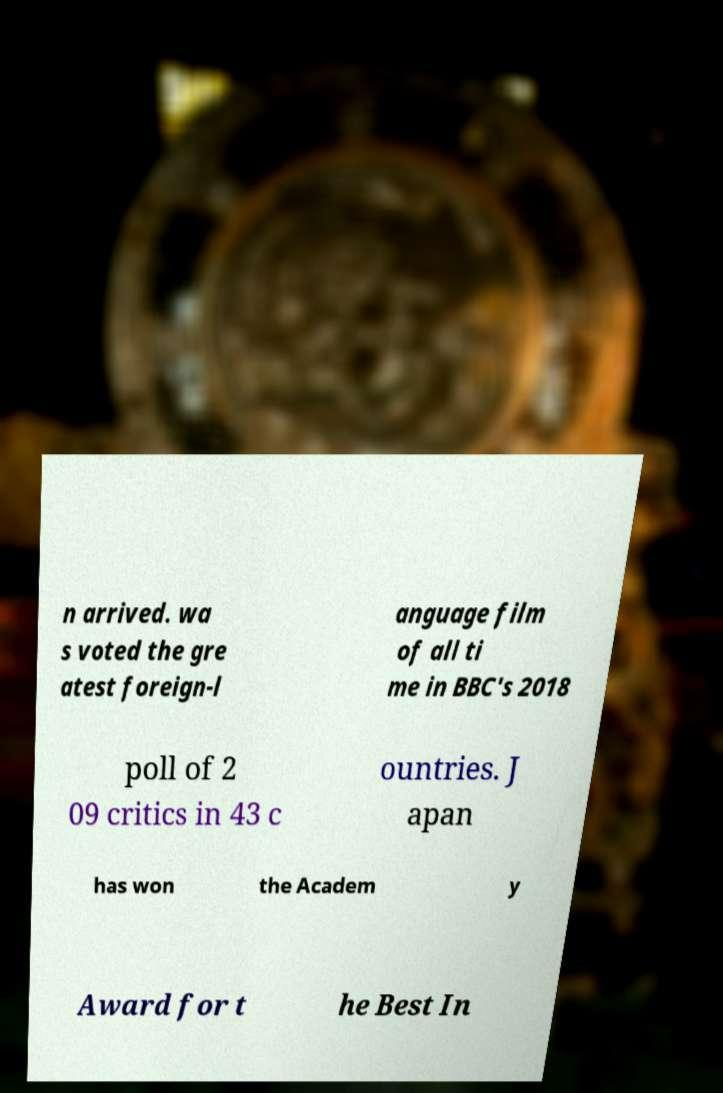What messages or text are displayed in this image? I need them in a readable, typed format. n arrived. wa s voted the gre atest foreign-l anguage film of all ti me in BBC's 2018 poll of 2 09 critics in 43 c ountries. J apan has won the Academ y Award for t he Best In 